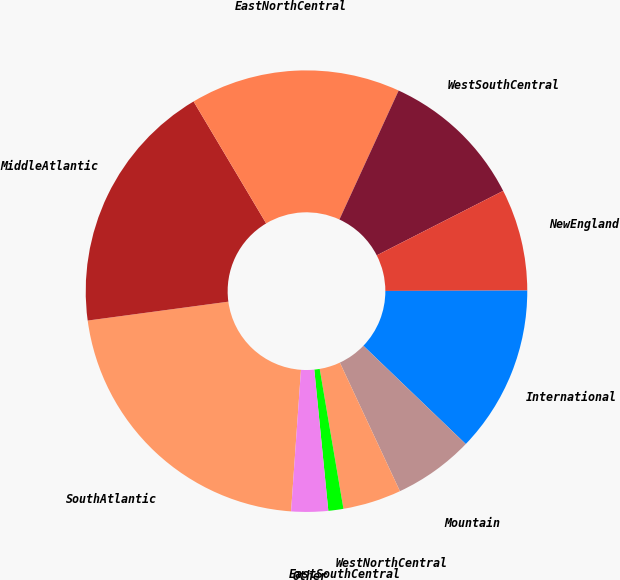Convert chart to OTSL. <chart><loc_0><loc_0><loc_500><loc_500><pie_chart><fcel>SouthAtlantic<fcel>MiddleAtlantic<fcel>EastNorthCentral<fcel>WestSouthCentral<fcel>NewEngland<fcel>International<fcel>Mountain<fcel>WestNorthCentral<fcel>EastSouthCentral<fcel>Other<nl><fcel>21.76%<fcel>18.58%<fcel>15.4%<fcel>10.64%<fcel>7.46%<fcel>12.22%<fcel>5.87%<fcel>4.28%<fcel>1.1%<fcel>2.69%<nl></chart> 